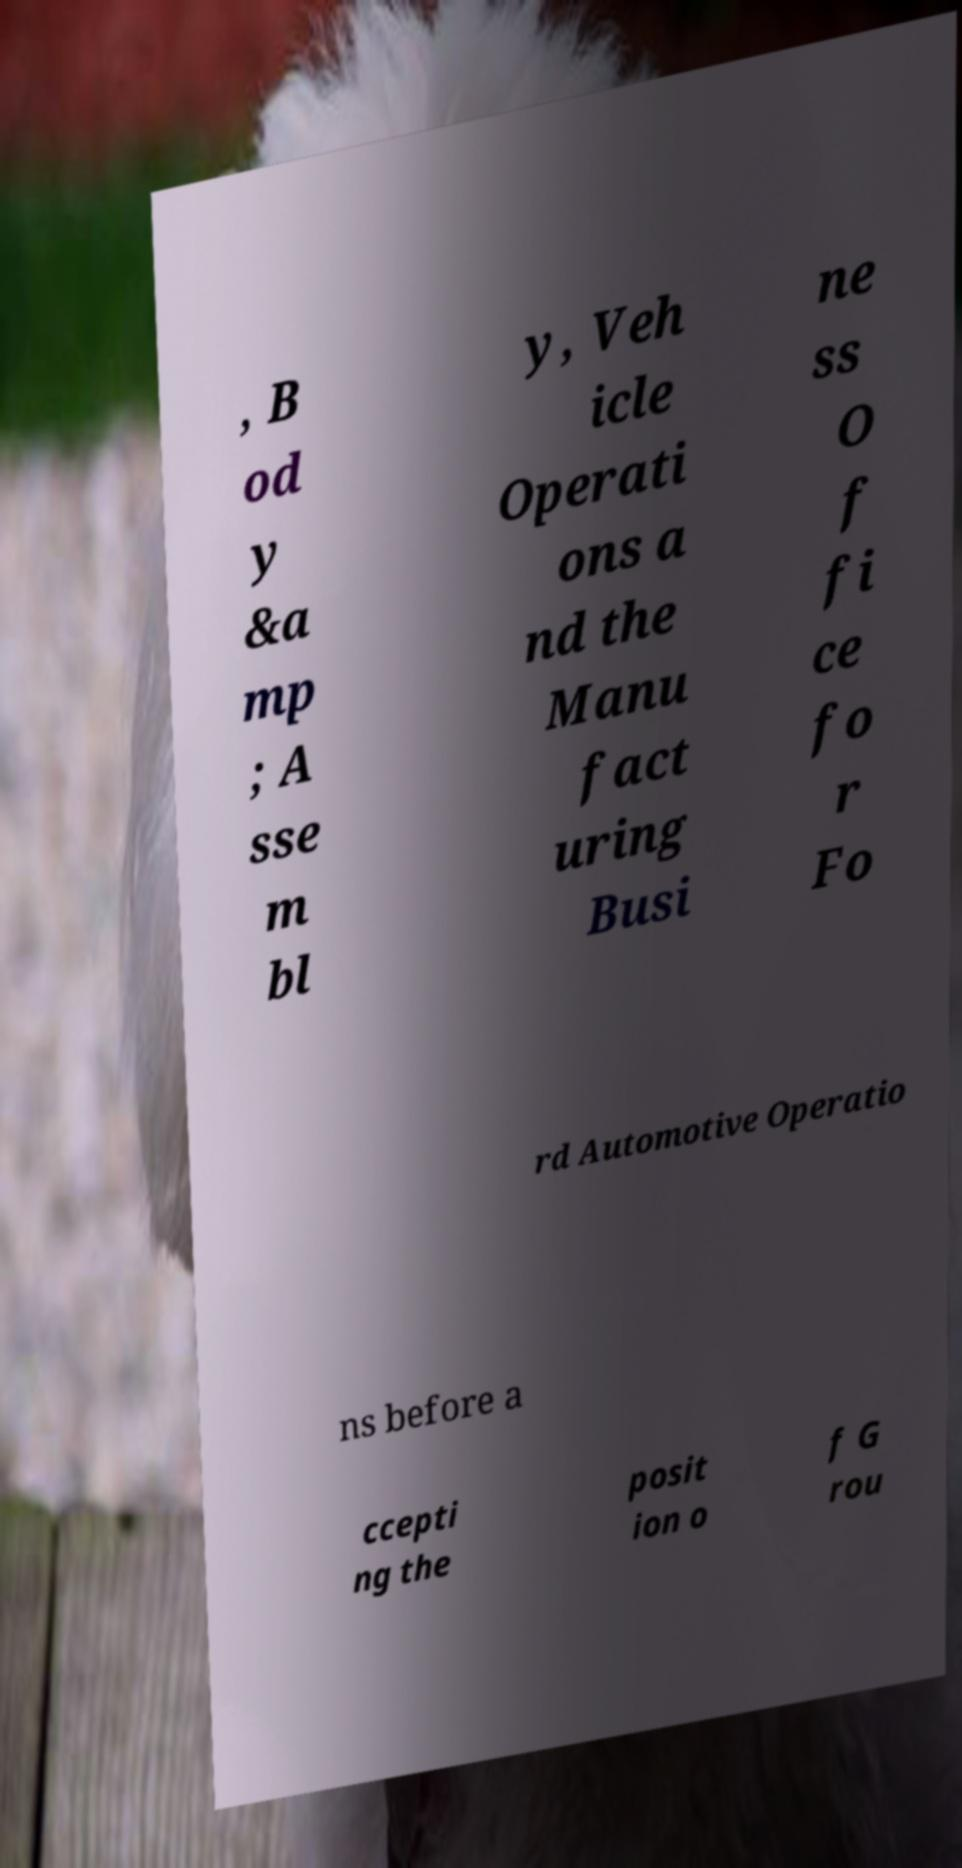What messages or text are displayed in this image? I need them in a readable, typed format. , B od y &a mp ; A sse m bl y, Veh icle Operati ons a nd the Manu fact uring Busi ne ss O f fi ce fo r Fo rd Automotive Operatio ns before a ccepti ng the posit ion o f G rou 